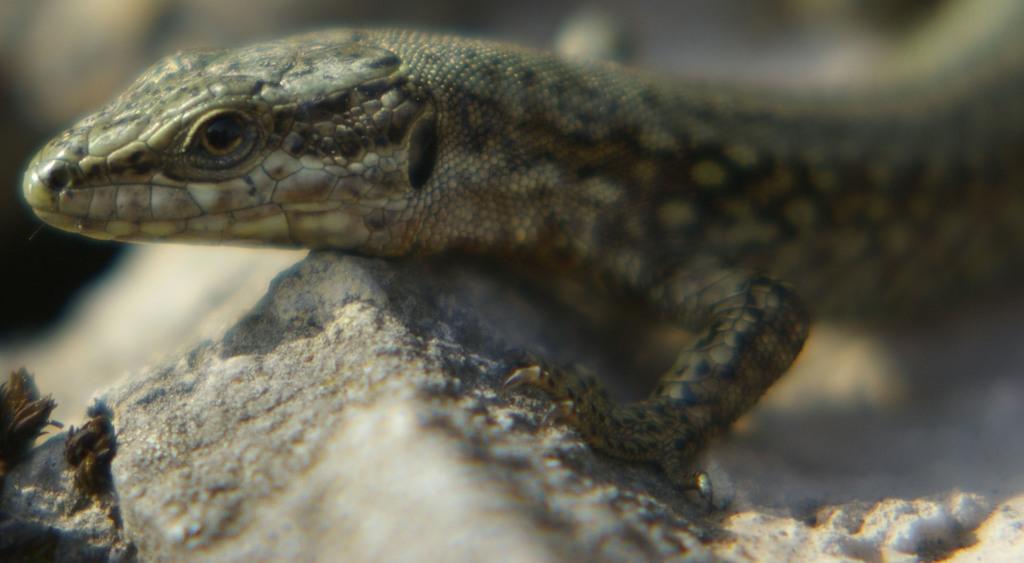Please provide a concise description of this image. In this picture we can see a lizard on a rock and in the background it is blurry. 